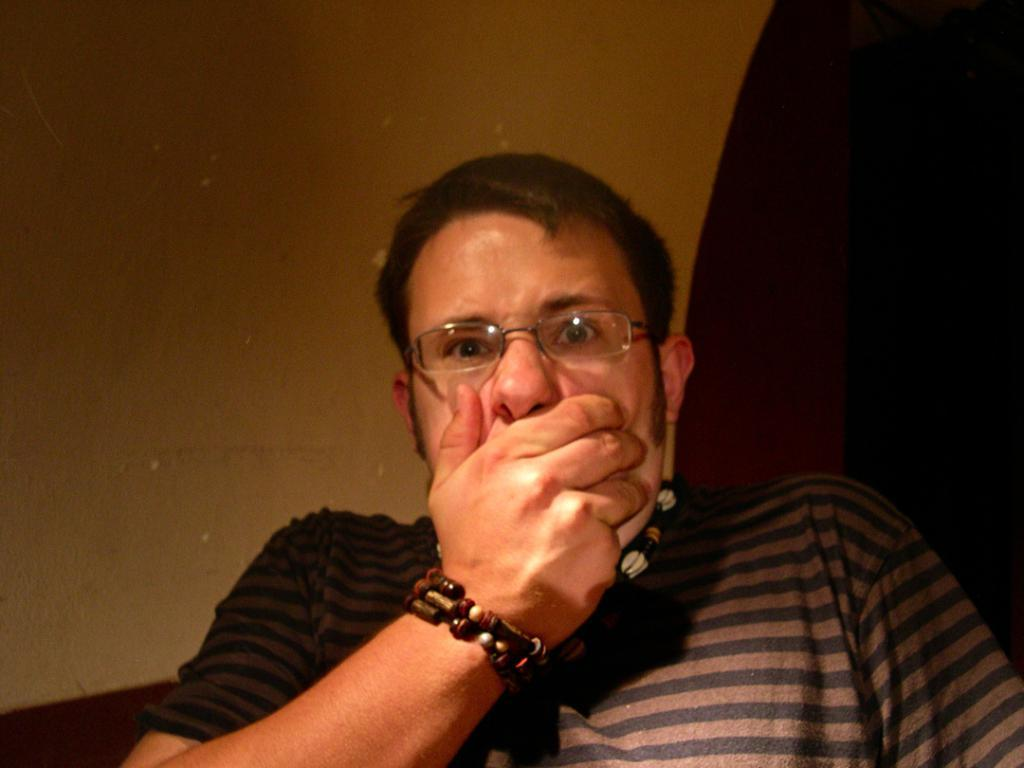What is located in the front of the image? There is a person in the front of the image. What can be seen in the background of the image? There is a wall in the background of the image. What type of event is being held in the image? There is no indication of an event being held in the image. What selection or sorting process is taking place in the image? There is no selection or sorting process visible in the image. 